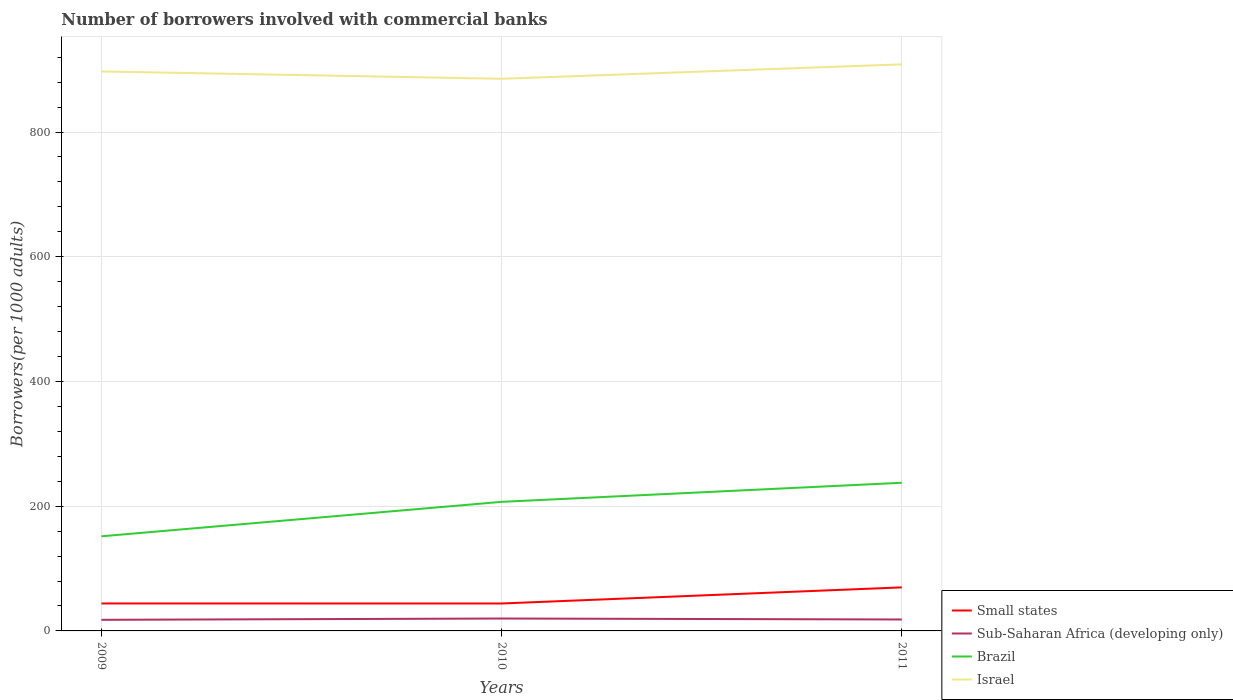How many different coloured lines are there?
Offer a terse response. 4. Is the number of lines equal to the number of legend labels?
Offer a terse response. Yes. Across all years, what is the maximum number of borrowers involved with commercial banks in Israel?
Your response must be concise. 885.37. What is the total number of borrowers involved with commercial banks in Israel in the graph?
Ensure brevity in your answer.  -23.15. What is the difference between the highest and the second highest number of borrowers involved with commercial banks in Small states?
Your response must be concise. 25.83. What is the difference between the highest and the lowest number of borrowers involved with commercial banks in Brazil?
Provide a short and direct response. 2. How many years are there in the graph?
Ensure brevity in your answer.  3. Does the graph contain any zero values?
Your answer should be compact. No. How many legend labels are there?
Give a very brief answer. 4. How are the legend labels stacked?
Your response must be concise. Vertical. What is the title of the graph?
Provide a short and direct response. Number of borrowers involved with commercial banks. What is the label or title of the X-axis?
Your answer should be compact. Years. What is the label or title of the Y-axis?
Give a very brief answer. Borrowers(per 1000 adults). What is the Borrowers(per 1000 adults) of Small states in 2009?
Offer a terse response. 44.03. What is the Borrowers(per 1000 adults) in Sub-Saharan Africa (developing only) in 2009?
Offer a very short reply. 17.81. What is the Borrowers(per 1000 adults) of Brazil in 2009?
Give a very brief answer. 151.74. What is the Borrowers(per 1000 adults) of Israel in 2009?
Provide a short and direct response. 897.16. What is the Borrowers(per 1000 adults) of Small states in 2010?
Provide a short and direct response. 44. What is the Borrowers(per 1000 adults) in Sub-Saharan Africa (developing only) in 2010?
Your answer should be very brief. 19.9. What is the Borrowers(per 1000 adults) of Brazil in 2010?
Keep it short and to the point. 206.97. What is the Borrowers(per 1000 adults) in Israel in 2010?
Make the answer very short. 885.37. What is the Borrowers(per 1000 adults) of Small states in 2011?
Provide a succinct answer. 69.83. What is the Borrowers(per 1000 adults) of Sub-Saharan Africa (developing only) in 2011?
Provide a short and direct response. 18.33. What is the Borrowers(per 1000 adults) of Brazil in 2011?
Your answer should be compact. 237.57. What is the Borrowers(per 1000 adults) in Israel in 2011?
Offer a terse response. 908.52. Across all years, what is the maximum Borrowers(per 1000 adults) of Small states?
Your answer should be very brief. 69.83. Across all years, what is the maximum Borrowers(per 1000 adults) in Sub-Saharan Africa (developing only)?
Ensure brevity in your answer.  19.9. Across all years, what is the maximum Borrowers(per 1000 adults) of Brazil?
Give a very brief answer. 237.57. Across all years, what is the maximum Borrowers(per 1000 adults) of Israel?
Make the answer very short. 908.52. Across all years, what is the minimum Borrowers(per 1000 adults) of Small states?
Provide a short and direct response. 44. Across all years, what is the minimum Borrowers(per 1000 adults) in Sub-Saharan Africa (developing only)?
Offer a terse response. 17.81. Across all years, what is the minimum Borrowers(per 1000 adults) in Brazil?
Your answer should be very brief. 151.74. Across all years, what is the minimum Borrowers(per 1000 adults) in Israel?
Offer a terse response. 885.37. What is the total Borrowers(per 1000 adults) in Small states in the graph?
Make the answer very short. 157.87. What is the total Borrowers(per 1000 adults) of Sub-Saharan Africa (developing only) in the graph?
Provide a succinct answer. 56.04. What is the total Borrowers(per 1000 adults) of Brazil in the graph?
Your answer should be very brief. 596.28. What is the total Borrowers(per 1000 adults) in Israel in the graph?
Offer a terse response. 2691.05. What is the difference between the Borrowers(per 1000 adults) in Small states in 2009 and that in 2010?
Ensure brevity in your answer.  0.03. What is the difference between the Borrowers(per 1000 adults) in Sub-Saharan Africa (developing only) in 2009 and that in 2010?
Provide a succinct answer. -2.1. What is the difference between the Borrowers(per 1000 adults) of Brazil in 2009 and that in 2010?
Provide a succinct answer. -55.23. What is the difference between the Borrowers(per 1000 adults) in Israel in 2009 and that in 2010?
Offer a terse response. 11.79. What is the difference between the Borrowers(per 1000 adults) in Small states in 2009 and that in 2011?
Keep it short and to the point. -25.8. What is the difference between the Borrowers(per 1000 adults) of Sub-Saharan Africa (developing only) in 2009 and that in 2011?
Your answer should be compact. -0.53. What is the difference between the Borrowers(per 1000 adults) in Brazil in 2009 and that in 2011?
Your answer should be very brief. -85.83. What is the difference between the Borrowers(per 1000 adults) of Israel in 2009 and that in 2011?
Provide a short and direct response. -11.36. What is the difference between the Borrowers(per 1000 adults) in Small states in 2010 and that in 2011?
Offer a terse response. -25.83. What is the difference between the Borrowers(per 1000 adults) in Sub-Saharan Africa (developing only) in 2010 and that in 2011?
Ensure brevity in your answer.  1.57. What is the difference between the Borrowers(per 1000 adults) of Brazil in 2010 and that in 2011?
Provide a short and direct response. -30.59. What is the difference between the Borrowers(per 1000 adults) of Israel in 2010 and that in 2011?
Ensure brevity in your answer.  -23.15. What is the difference between the Borrowers(per 1000 adults) in Small states in 2009 and the Borrowers(per 1000 adults) in Sub-Saharan Africa (developing only) in 2010?
Your response must be concise. 24.13. What is the difference between the Borrowers(per 1000 adults) of Small states in 2009 and the Borrowers(per 1000 adults) of Brazil in 2010?
Ensure brevity in your answer.  -162.94. What is the difference between the Borrowers(per 1000 adults) in Small states in 2009 and the Borrowers(per 1000 adults) in Israel in 2010?
Offer a terse response. -841.34. What is the difference between the Borrowers(per 1000 adults) of Sub-Saharan Africa (developing only) in 2009 and the Borrowers(per 1000 adults) of Brazil in 2010?
Provide a short and direct response. -189.17. What is the difference between the Borrowers(per 1000 adults) in Sub-Saharan Africa (developing only) in 2009 and the Borrowers(per 1000 adults) in Israel in 2010?
Give a very brief answer. -867.56. What is the difference between the Borrowers(per 1000 adults) in Brazil in 2009 and the Borrowers(per 1000 adults) in Israel in 2010?
Your answer should be very brief. -733.63. What is the difference between the Borrowers(per 1000 adults) in Small states in 2009 and the Borrowers(per 1000 adults) in Sub-Saharan Africa (developing only) in 2011?
Ensure brevity in your answer.  25.7. What is the difference between the Borrowers(per 1000 adults) in Small states in 2009 and the Borrowers(per 1000 adults) in Brazil in 2011?
Ensure brevity in your answer.  -193.54. What is the difference between the Borrowers(per 1000 adults) of Small states in 2009 and the Borrowers(per 1000 adults) of Israel in 2011?
Ensure brevity in your answer.  -864.49. What is the difference between the Borrowers(per 1000 adults) of Sub-Saharan Africa (developing only) in 2009 and the Borrowers(per 1000 adults) of Brazil in 2011?
Your response must be concise. -219.76. What is the difference between the Borrowers(per 1000 adults) in Sub-Saharan Africa (developing only) in 2009 and the Borrowers(per 1000 adults) in Israel in 2011?
Your answer should be very brief. -890.72. What is the difference between the Borrowers(per 1000 adults) in Brazil in 2009 and the Borrowers(per 1000 adults) in Israel in 2011?
Make the answer very short. -756.78. What is the difference between the Borrowers(per 1000 adults) of Small states in 2010 and the Borrowers(per 1000 adults) of Sub-Saharan Africa (developing only) in 2011?
Provide a succinct answer. 25.67. What is the difference between the Borrowers(per 1000 adults) of Small states in 2010 and the Borrowers(per 1000 adults) of Brazil in 2011?
Your answer should be very brief. -193.56. What is the difference between the Borrowers(per 1000 adults) in Small states in 2010 and the Borrowers(per 1000 adults) in Israel in 2011?
Keep it short and to the point. -864.52. What is the difference between the Borrowers(per 1000 adults) of Sub-Saharan Africa (developing only) in 2010 and the Borrowers(per 1000 adults) of Brazil in 2011?
Ensure brevity in your answer.  -217.67. What is the difference between the Borrowers(per 1000 adults) in Sub-Saharan Africa (developing only) in 2010 and the Borrowers(per 1000 adults) in Israel in 2011?
Ensure brevity in your answer.  -888.62. What is the difference between the Borrowers(per 1000 adults) of Brazil in 2010 and the Borrowers(per 1000 adults) of Israel in 2011?
Ensure brevity in your answer.  -701.55. What is the average Borrowers(per 1000 adults) of Small states per year?
Provide a short and direct response. 52.62. What is the average Borrowers(per 1000 adults) of Sub-Saharan Africa (developing only) per year?
Give a very brief answer. 18.68. What is the average Borrowers(per 1000 adults) in Brazil per year?
Your answer should be compact. 198.76. What is the average Borrowers(per 1000 adults) of Israel per year?
Your answer should be compact. 897.02. In the year 2009, what is the difference between the Borrowers(per 1000 adults) in Small states and Borrowers(per 1000 adults) in Sub-Saharan Africa (developing only)?
Your response must be concise. 26.22. In the year 2009, what is the difference between the Borrowers(per 1000 adults) of Small states and Borrowers(per 1000 adults) of Brazil?
Provide a short and direct response. -107.71. In the year 2009, what is the difference between the Borrowers(per 1000 adults) in Small states and Borrowers(per 1000 adults) in Israel?
Your response must be concise. -853.13. In the year 2009, what is the difference between the Borrowers(per 1000 adults) of Sub-Saharan Africa (developing only) and Borrowers(per 1000 adults) of Brazil?
Offer a terse response. -133.93. In the year 2009, what is the difference between the Borrowers(per 1000 adults) in Sub-Saharan Africa (developing only) and Borrowers(per 1000 adults) in Israel?
Give a very brief answer. -879.35. In the year 2009, what is the difference between the Borrowers(per 1000 adults) in Brazil and Borrowers(per 1000 adults) in Israel?
Provide a succinct answer. -745.42. In the year 2010, what is the difference between the Borrowers(per 1000 adults) in Small states and Borrowers(per 1000 adults) in Sub-Saharan Africa (developing only)?
Make the answer very short. 24.1. In the year 2010, what is the difference between the Borrowers(per 1000 adults) in Small states and Borrowers(per 1000 adults) in Brazil?
Make the answer very short. -162.97. In the year 2010, what is the difference between the Borrowers(per 1000 adults) in Small states and Borrowers(per 1000 adults) in Israel?
Provide a succinct answer. -841.37. In the year 2010, what is the difference between the Borrowers(per 1000 adults) of Sub-Saharan Africa (developing only) and Borrowers(per 1000 adults) of Brazil?
Ensure brevity in your answer.  -187.07. In the year 2010, what is the difference between the Borrowers(per 1000 adults) in Sub-Saharan Africa (developing only) and Borrowers(per 1000 adults) in Israel?
Ensure brevity in your answer.  -865.47. In the year 2010, what is the difference between the Borrowers(per 1000 adults) of Brazil and Borrowers(per 1000 adults) of Israel?
Offer a terse response. -678.4. In the year 2011, what is the difference between the Borrowers(per 1000 adults) in Small states and Borrowers(per 1000 adults) in Sub-Saharan Africa (developing only)?
Provide a succinct answer. 51.5. In the year 2011, what is the difference between the Borrowers(per 1000 adults) of Small states and Borrowers(per 1000 adults) of Brazil?
Provide a succinct answer. -167.74. In the year 2011, what is the difference between the Borrowers(per 1000 adults) in Small states and Borrowers(per 1000 adults) in Israel?
Your answer should be very brief. -838.69. In the year 2011, what is the difference between the Borrowers(per 1000 adults) in Sub-Saharan Africa (developing only) and Borrowers(per 1000 adults) in Brazil?
Provide a short and direct response. -219.24. In the year 2011, what is the difference between the Borrowers(per 1000 adults) in Sub-Saharan Africa (developing only) and Borrowers(per 1000 adults) in Israel?
Give a very brief answer. -890.19. In the year 2011, what is the difference between the Borrowers(per 1000 adults) in Brazil and Borrowers(per 1000 adults) in Israel?
Give a very brief answer. -670.95. What is the ratio of the Borrowers(per 1000 adults) of Small states in 2009 to that in 2010?
Ensure brevity in your answer.  1. What is the ratio of the Borrowers(per 1000 adults) in Sub-Saharan Africa (developing only) in 2009 to that in 2010?
Offer a terse response. 0.89. What is the ratio of the Borrowers(per 1000 adults) of Brazil in 2009 to that in 2010?
Offer a very short reply. 0.73. What is the ratio of the Borrowers(per 1000 adults) in Israel in 2009 to that in 2010?
Ensure brevity in your answer.  1.01. What is the ratio of the Borrowers(per 1000 adults) of Small states in 2009 to that in 2011?
Make the answer very short. 0.63. What is the ratio of the Borrowers(per 1000 adults) of Sub-Saharan Africa (developing only) in 2009 to that in 2011?
Ensure brevity in your answer.  0.97. What is the ratio of the Borrowers(per 1000 adults) in Brazil in 2009 to that in 2011?
Offer a terse response. 0.64. What is the ratio of the Borrowers(per 1000 adults) of Israel in 2009 to that in 2011?
Offer a very short reply. 0.99. What is the ratio of the Borrowers(per 1000 adults) of Small states in 2010 to that in 2011?
Your response must be concise. 0.63. What is the ratio of the Borrowers(per 1000 adults) in Sub-Saharan Africa (developing only) in 2010 to that in 2011?
Offer a very short reply. 1.09. What is the ratio of the Borrowers(per 1000 adults) of Brazil in 2010 to that in 2011?
Provide a short and direct response. 0.87. What is the ratio of the Borrowers(per 1000 adults) in Israel in 2010 to that in 2011?
Ensure brevity in your answer.  0.97. What is the difference between the highest and the second highest Borrowers(per 1000 adults) of Small states?
Offer a terse response. 25.8. What is the difference between the highest and the second highest Borrowers(per 1000 adults) of Sub-Saharan Africa (developing only)?
Your answer should be compact. 1.57. What is the difference between the highest and the second highest Borrowers(per 1000 adults) of Brazil?
Provide a short and direct response. 30.59. What is the difference between the highest and the second highest Borrowers(per 1000 adults) of Israel?
Your response must be concise. 11.36. What is the difference between the highest and the lowest Borrowers(per 1000 adults) in Small states?
Your answer should be very brief. 25.83. What is the difference between the highest and the lowest Borrowers(per 1000 adults) of Sub-Saharan Africa (developing only)?
Your response must be concise. 2.1. What is the difference between the highest and the lowest Borrowers(per 1000 adults) in Brazil?
Keep it short and to the point. 85.83. What is the difference between the highest and the lowest Borrowers(per 1000 adults) of Israel?
Give a very brief answer. 23.15. 